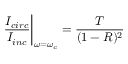Convert formula to latex. <formula><loc_0><loc_0><loc_500><loc_500>\frac { I _ { c i r c } } { I _ { i n c } } \right | _ { \omega = \omega _ { c } } = \frac { T } { ( 1 - R ) ^ { 2 } }</formula> 